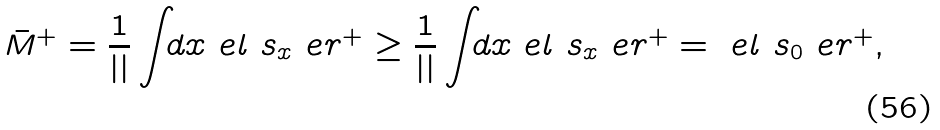<formula> <loc_0><loc_0><loc_500><loc_500>\bar { M } ^ { + } _ { \L } = \frac { 1 } { | \L | } \int _ { \L } d x \ e l \ s _ { x } \ e r ^ { + } _ { \L } \geq \frac { 1 } { | \L | } \int _ { \L } d x \ e l \ s _ { x } \ e r ^ { + } = \ e l \ s _ { 0 } \ e r ^ { + } ,</formula> 